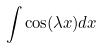Convert formula to latex. <formula><loc_0><loc_0><loc_500><loc_500>\int \cos ( \lambda x ) d x</formula> 